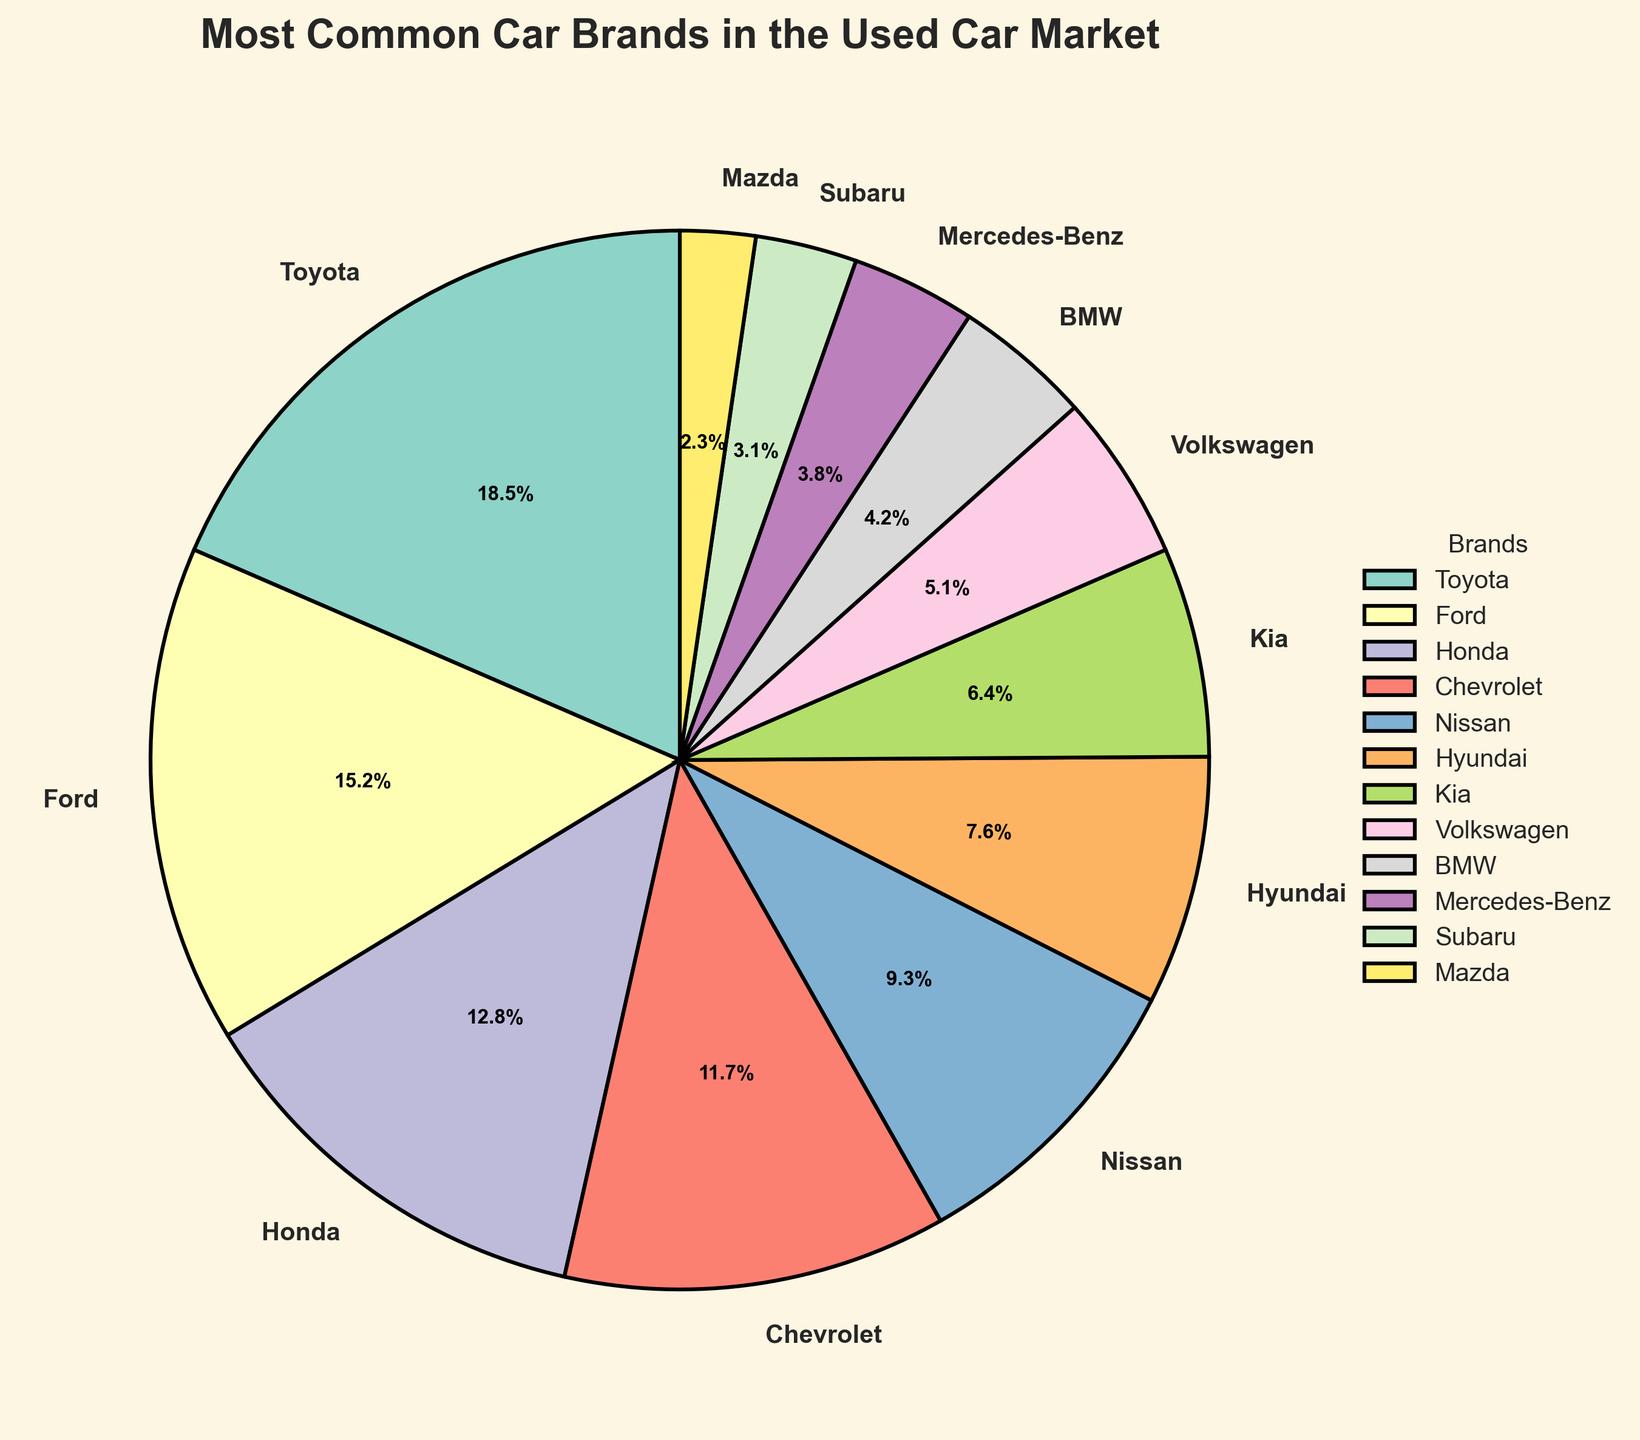What percentage of the used car market is made up by Toyota, Ford, and Honda combined? Toyota accounts for 18.5%, Ford accounts for 15.2%, and Honda accounts for 12.8%. The combined percentage is 18.5 + 15.2 + 12.8 which equals 46.5%.
Answer: 46.5% Which brand holds the smallest share in the used car market? The smallest percentage is 2.3%, which corresponds to Mazda.
Answer: Mazda Are there more Toyota cars or Chevrolet cars in the used car market? Toyota accounts for 18.5% of the market, while Chevrolet accounts for 11.7%. Therefore, there are more Toyota cars than Chevrolet cars.
Answer: Toyota What is the percentage difference between the market shares of Hyundai and Mercedes-Benz? Hyundai has 7.6% of the market, and Mercedes-Benz has 3.8%. The difference is 7.6 - 3.8 which equals 3.8%.
Answer: 3.8% Which color is associated with the wedge representing BMW? The BMW wedge is visualized using a color from the Set3 color palette. Observing the pie chart, the color corresponding to BMW is visually seen as one of the distinct colors.
Answer: (Specific color — this will be a straightforward observation from the chart) What is the total percentage of the used car market that is composed of European brands (Volkswagen, BMW, Mercedes-Benz)? Volkswagen accounts for 5.1%, BMW for 4.2%, and Mercedes-Benz for 3.8%. Adding these gives 5.1 + 4.2 + 3.8 which equals 13.1%.
Answer: 13.1% Which brand would you choose between Nissan and Kia if you were looking for a higher market share in the used car market? Nissan has a market share of 9.3%, while Kia has a market share of 6.4%. Therefore, Nissan has a higher market share.
Answer: Nissan What's the combined market share of brands with at least 10% share? The brands with at least 10% share are Toyota (18.5%), Ford (15.2%), and Honda (12.8%). Their combined share is 18.5 + 15.2 + 12.8 which equals 46.5%.
Answer: 46.5% Which brand has the higher market share: Hyundai or Subaru? Hyundai accounts for 7.6% and Subaru for 3.1%. Therefore, Hyundai has a higher market share.
Answer: Hyundai What is the average market share of the brands listed in the chart? To find the average, add all the percentages and divide by the number of brands. The sum is 18.5 + 15.2 + 12.8 + 11.7 + 9.3 + 7.6 + 6.4 + 5.1 + 4.2 + 3.8 + 3.1 + 2.3 which equals 99.0. Dividing by the 12 brands gives 99.0 / 12 which roughly equals 8.25%.
Answer: 8.25% 